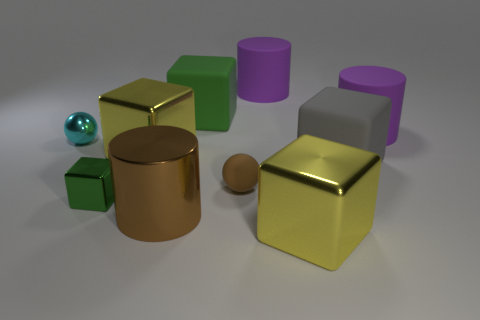Is the material of the tiny cyan sphere the same as the green block in front of the brown sphere?
Your response must be concise. Yes. What color is the large matte block that is on the left side of the big matte cube that is in front of the shiny sphere?
Provide a short and direct response. Green. Are there any other cylinders of the same color as the large metal cylinder?
Make the answer very short. No. There is a sphere that is on the right side of the cylinder that is in front of the big yellow shiny object behind the green metallic object; what size is it?
Keep it short and to the point. Small. There is a cyan thing; is it the same shape as the gray object to the right of the big green matte object?
Your answer should be compact. No. How many other things are there of the same size as the brown metal cylinder?
Keep it short and to the point. 6. There is a green cube that is in front of the tiny cyan ball; how big is it?
Keep it short and to the point. Small. What number of gray blocks are the same material as the small green thing?
Your answer should be compact. 0. There is a large yellow thing that is in front of the brown rubber object; is it the same shape as the green metal thing?
Keep it short and to the point. Yes. There is a large yellow shiny object that is on the right side of the brown matte ball; what is its shape?
Your answer should be compact. Cube. 